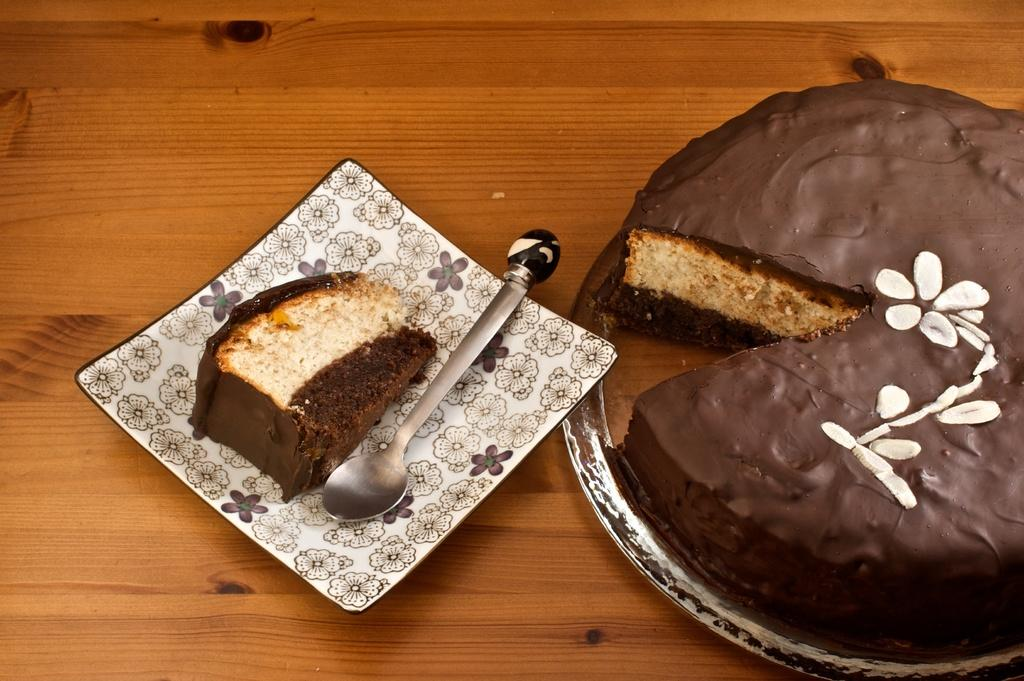What is on the plate that is visible in the image? There is a piece of cake on the plate in the image. What utensil can be seen in the image? There is a spoon placed on the wooden surface in the image. Where is the cake located in the image? There is a cake in a plate on the right side of the image. How many kittens are playing with the spoon in the image? There are no kittens present in the image, and therefore no such activity can be observed. 